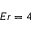Convert formula to latex. <formula><loc_0><loc_0><loc_500><loc_500>E r = 4</formula> 